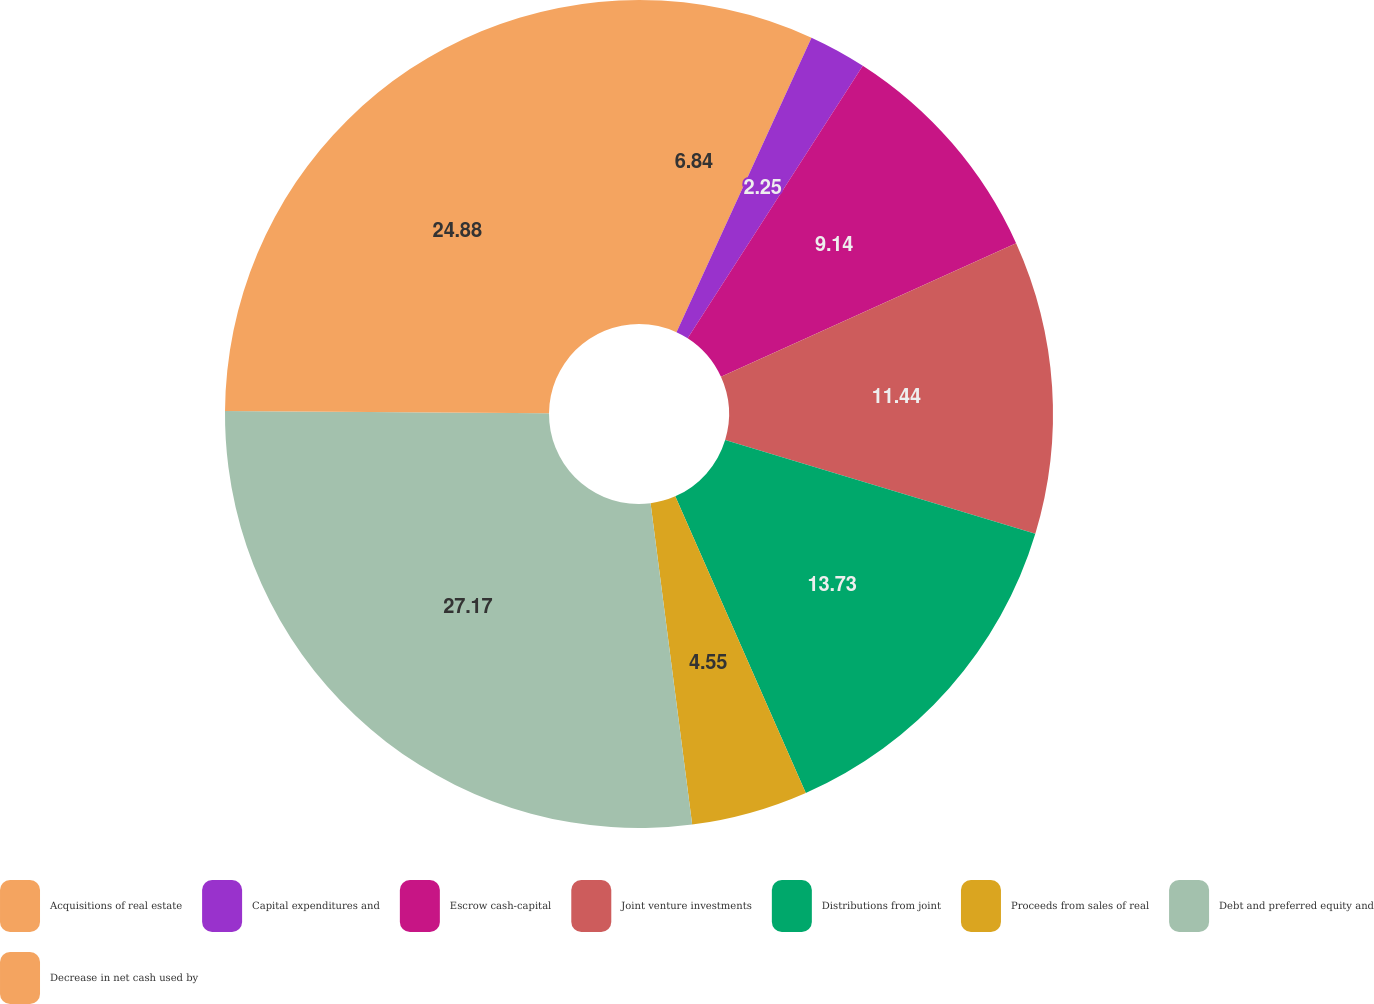Convert chart to OTSL. <chart><loc_0><loc_0><loc_500><loc_500><pie_chart><fcel>Acquisitions of real estate<fcel>Capital expenditures and<fcel>Escrow cash-capital<fcel>Joint venture investments<fcel>Distributions from joint<fcel>Proceeds from sales of real<fcel>Debt and preferred equity and<fcel>Decrease in net cash used by<nl><fcel>6.84%<fcel>2.25%<fcel>9.14%<fcel>11.44%<fcel>13.73%<fcel>4.55%<fcel>27.17%<fcel>24.88%<nl></chart> 